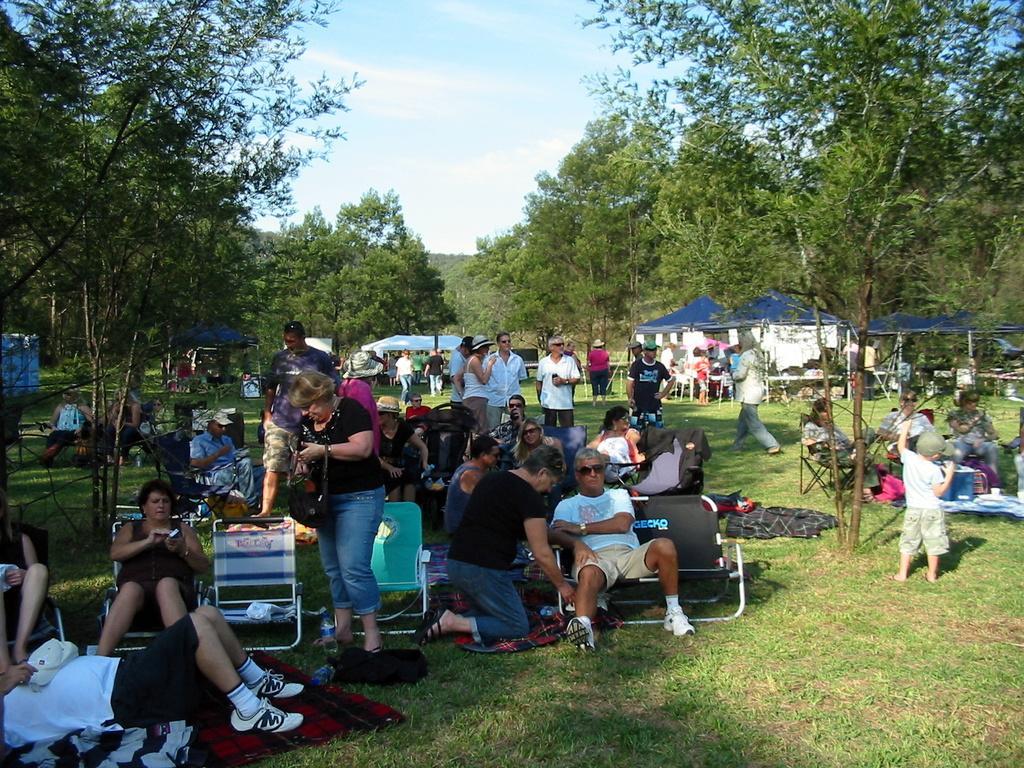How would you summarize this image in a sentence or two? In this image there are some people some of them are sitting and some of them are lying and some of them are walking, and also we could see some chairs and tents and some umbrellas. At the bottom there is grass, and on the grass there are some blankets and some clothes. In the background there are some trees, and at the top of the image there is sky. 